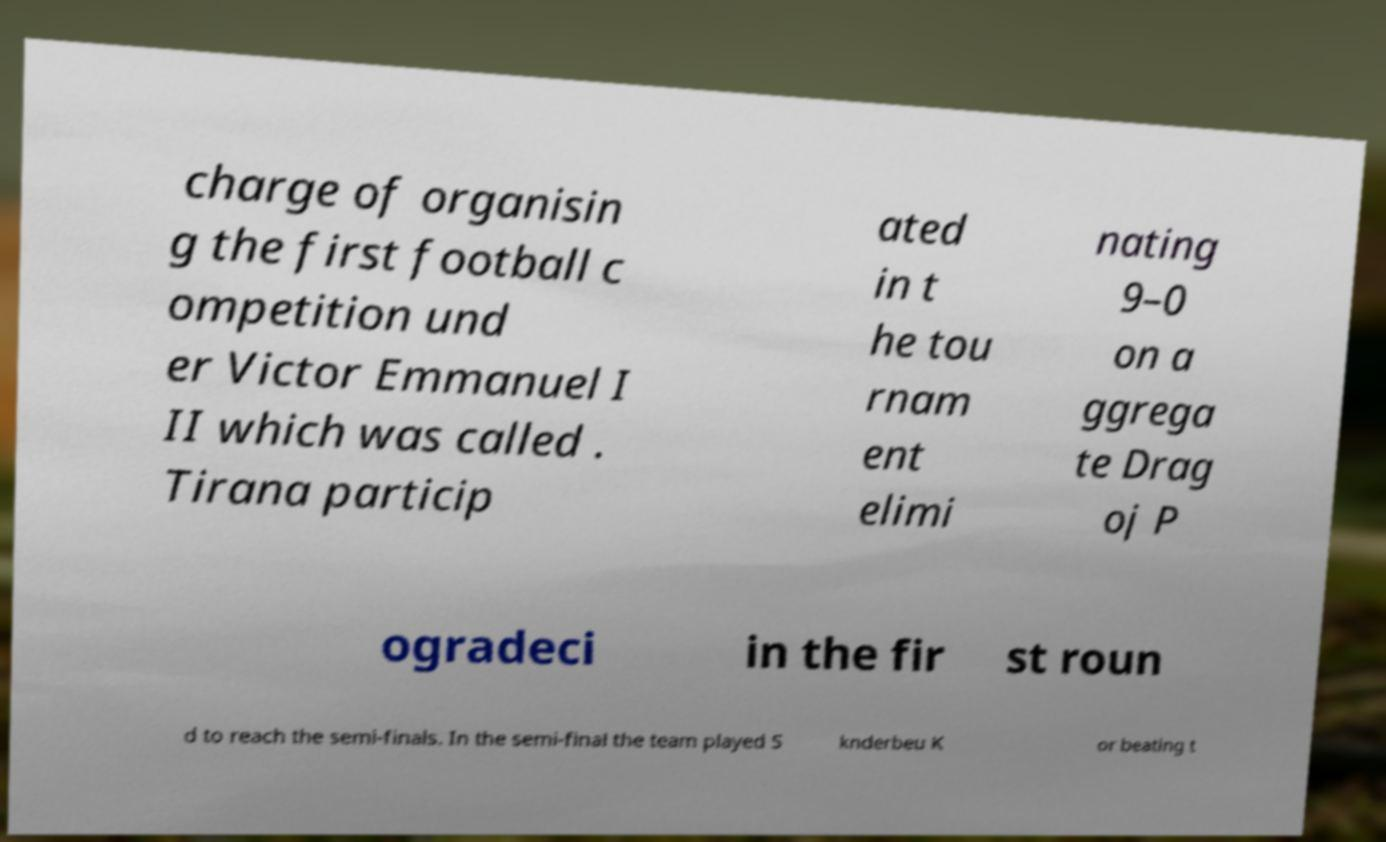There's text embedded in this image that I need extracted. Can you transcribe it verbatim? charge of organisin g the first football c ompetition und er Victor Emmanuel I II which was called . Tirana particip ated in t he tou rnam ent elimi nating 9–0 on a ggrega te Drag oj P ogradeci in the fir st roun d to reach the semi-finals. In the semi-final the team played S knderbeu K or beating t 